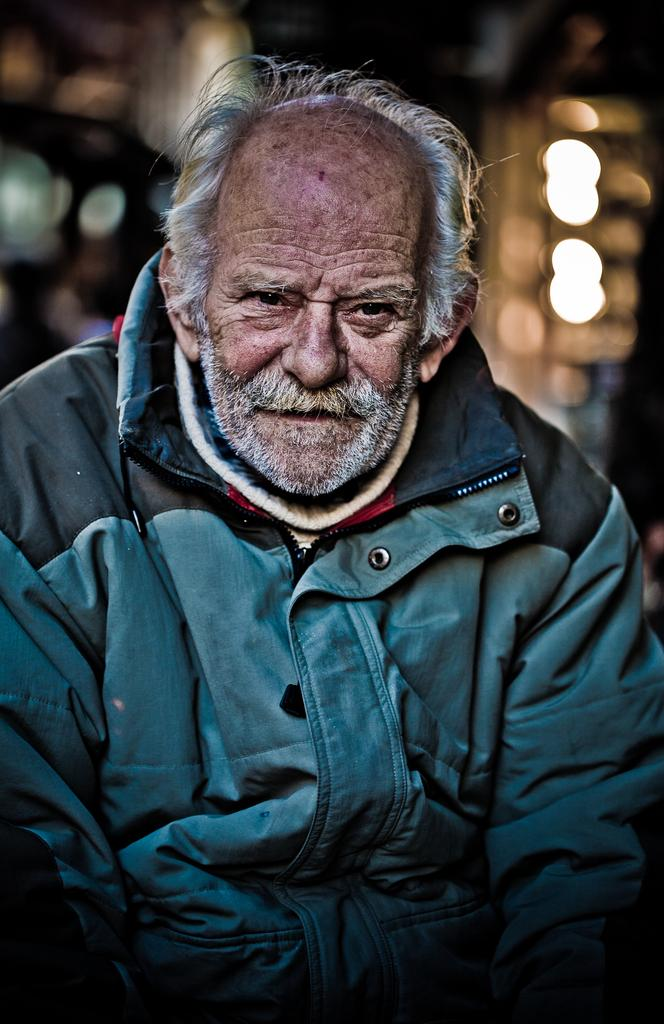Who is the main subject in the image? There is an old man in the image. What is the old man wearing? The old man is wearing a blue jacket. What type of jewel can be seen on the mountain in the image? There is no mountain or jewel present in the image; it only features an old man wearing a blue jacket. What kind of party is happening in the image? There is no party depicted in the image; it only features an old man wearing a blue jacket. 